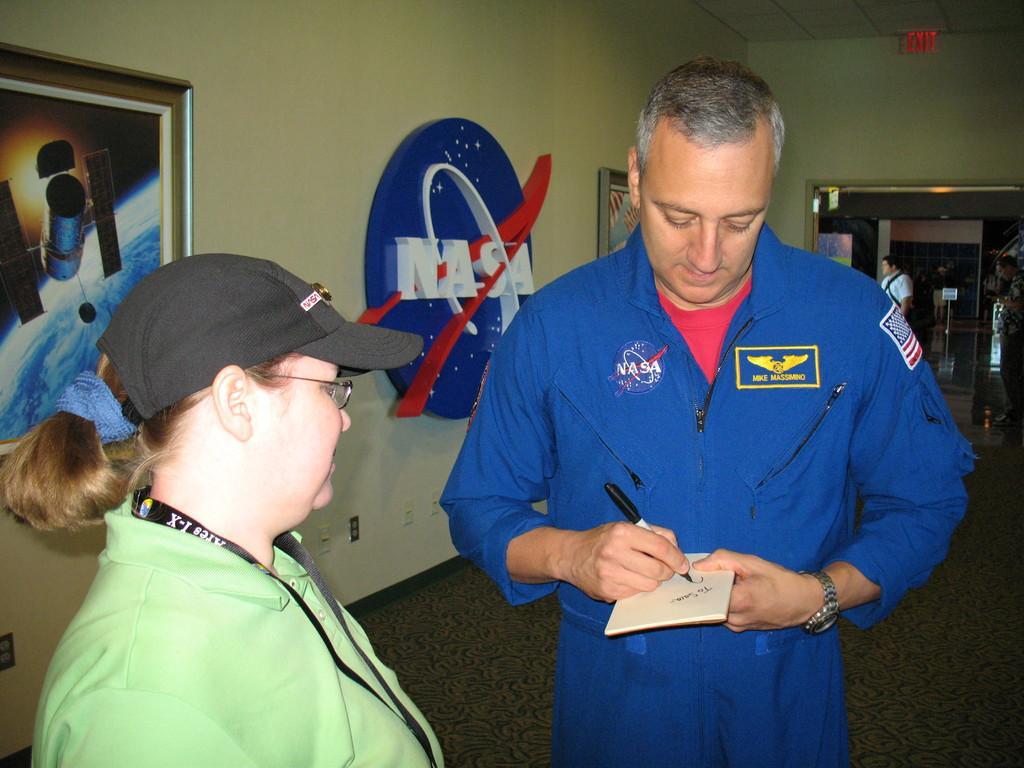How would you summarize this image in a sentence or two? This image is taken indoors. At the bottom of the image there is a floor. On the left side of the image a woman is standing on the floor. In the middle of the image a man is standing on the book and writing with a pen. In the background there is a wall with a picture frame and a board with text on it. On the right side of the image a person is standing on the floor and there is a door. 